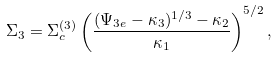Convert formula to latex. <formula><loc_0><loc_0><loc_500><loc_500>\Sigma _ { 3 } = \Sigma _ { c } ^ { ( 3 ) } \left ( \frac { ( \Psi _ { 3 e } - \kappa _ { 3 } ) ^ { 1 / 3 } - \kappa _ { 2 } } { \kappa _ { 1 } } \right ) ^ { 5 / 2 } ,</formula> 